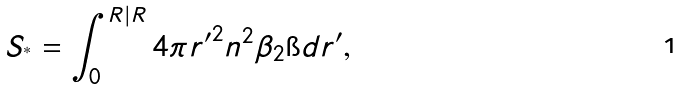Convert formula to latex. <formula><loc_0><loc_0><loc_500><loc_500>S _ { ^ { * } } = \int _ { 0 } ^ { R | R } 4 \pi { r ^ { \prime } } ^ { 2 } n ^ { 2 } \beta _ { 2 } \i d { r ^ { \prime } } ,</formula> 